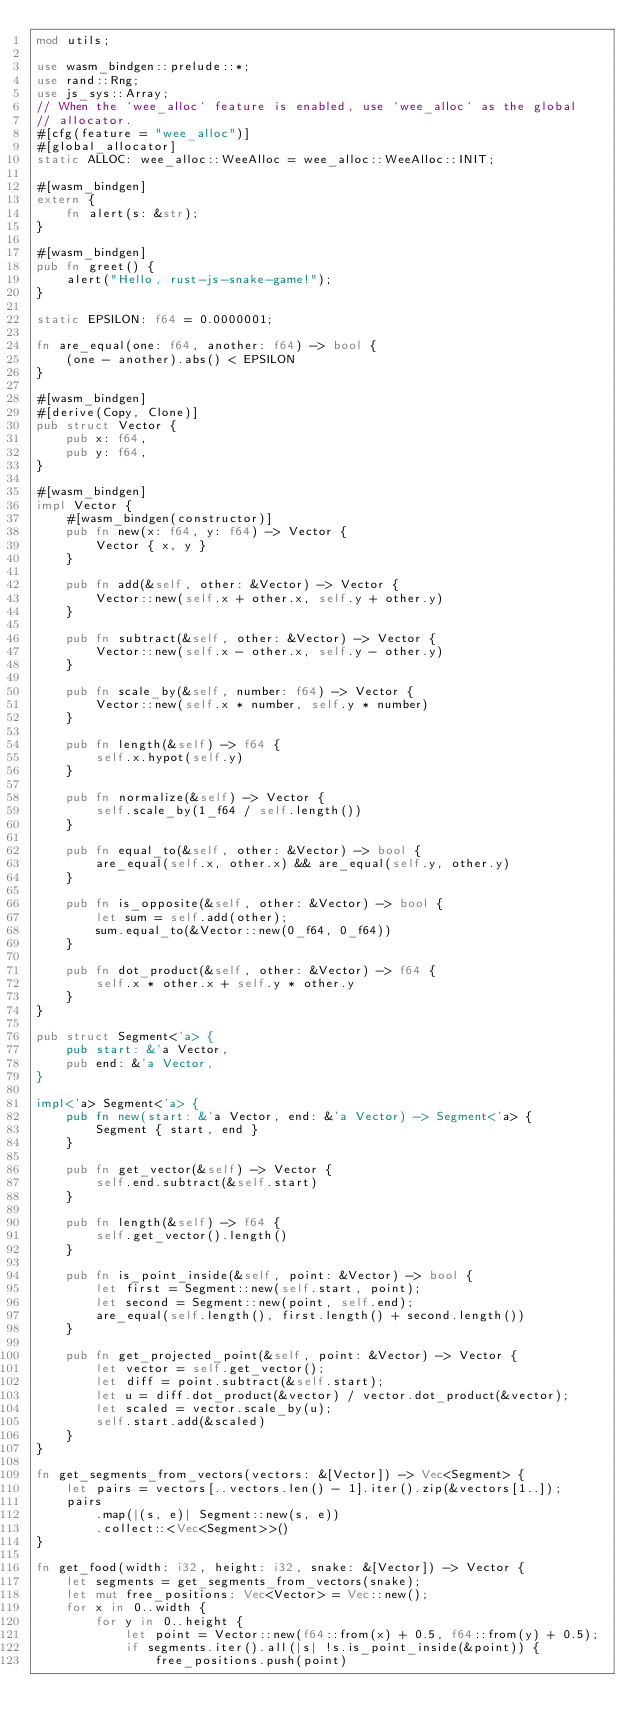Convert code to text. <code><loc_0><loc_0><loc_500><loc_500><_Rust_>mod utils;

use wasm_bindgen::prelude::*;
use rand::Rng;
use js_sys::Array;
// When the `wee_alloc` feature is enabled, use `wee_alloc` as the global
// allocator.
#[cfg(feature = "wee_alloc")]
#[global_allocator]
static ALLOC: wee_alloc::WeeAlloc = wee_alloc::WeeAlloc::INIT;

#[wasm_bindgen]
extern {
    fn alert(s: &str);
}

#[wasm_bindgen]
pub fn greet() {
    alert("Hello, rust-js-snake-game!");
}

static EPSILON: f64 = 0.0000001;

fn are_equal(one: f64, another: f64) -> bool {
    (one - another).abs() < EPSILON
}

#[wasm_bindgen]
#[derive(Copy, Clone)]
pub struct Vector {
    pub x: f64,
    pub y: f64,
}

#[wasm_bindgen]
impl Vector {
    #[wasm_bindgen(constructor)]
    pub fn new(x: f64, y: f64) -> Vector {
        Vector { x, y }
    }

    pub fn add(&self, other: &Vector) -> Vector {
        Vector::new(self.x + other.x, self.y + other.y)
    }

    pub fn subtract(&self, other: &Vector) -> Vector {
        Vector::new(self.x - other.x, self.y - other.y)
    }

    pub fn scale_by(&self, number: f64) -> Vector {
        Vector::new(self.x * number, self.y * number)
    }

    pub fn length(&self) -> f64 {
        self.x.hypot(self.y)
    }

    pub fn normalize(&self) -> Vector {
        self.scale_by(1_f64 / self.length())
    }

    pub fn equal_to(&self, other: &Vector) -> bool {
        are_equal(self.x, other.x) && are_equal(self.y, other.y)
    }

    pub fn is_opposite(&self, other: &Vector) -> bool {
        let sum = self.add(other);
        sum.equal_to(&Vector::new(0_f64, 0_f64))
    }

    pub fn dot_product(&self, other: &Vector) -> f64 {
        self.x * other.x + self.y * other.y
    }
}

pub struct Segment<'a> {
    pub start: &'a Vector,
    pub end: &'a Vector,
}

impl<'a> Segment<'a> {
    pub fn new(start: &'a Vector, end: &'a Vector) -> Segment<'a> {
        Segment { start, end }
    }

    pub fn get_vector(&self) -> Vector {
        self.end.subtract(&self.start)
    }

    pub fn length(&self) -> f64 {
        self.get_vector().length()
    }

    pub fn is_point_inside(&self, point: &Vector) -> bool {
        let first = Segment::new(self.start, point);
        let second = Segment::new(point, self.end);
        are_equal(self.length(), first.length() + second.length())
    }

    pub fn get_projected_point(&self, point: &Vector) -> Vector {
        let vector = self.get_vector();
        let diff = point.subtract(&self.start);
        let u = diff.dot_product(&vector) / vector.dot_product(&vector);
        let scaled = vector.scale_by(u);
        self.start.add(&scaled)
    }
}

fn get_segments_from_vectors(vectors: &[Vector]) -> Vec<Segment> {
    let pairs = vectors[..vectors.len() - 1].iter().zip(&vectors[1..]);
    pairs
        .map(|(s, e)| Segment::new(s, e))
        .collect::<Vec<Segment>>()
}

fn get_food(width: i32, height: i32, snake: &[Vector]) -> Vector {
    let segments = get_segments_from_vectors(snake);
    let mut free_positions: Vec<Vector> = Vec::new();
    for x in 0..width {
        for y in 0..height {
            let point = Vector::new(f64::from(x) + 0.5, f64::from(y) + 0.5);
            if segments.iter().all(|s| !s.is_point_inside(&point)) {
                free_positions.push(point)</code> 